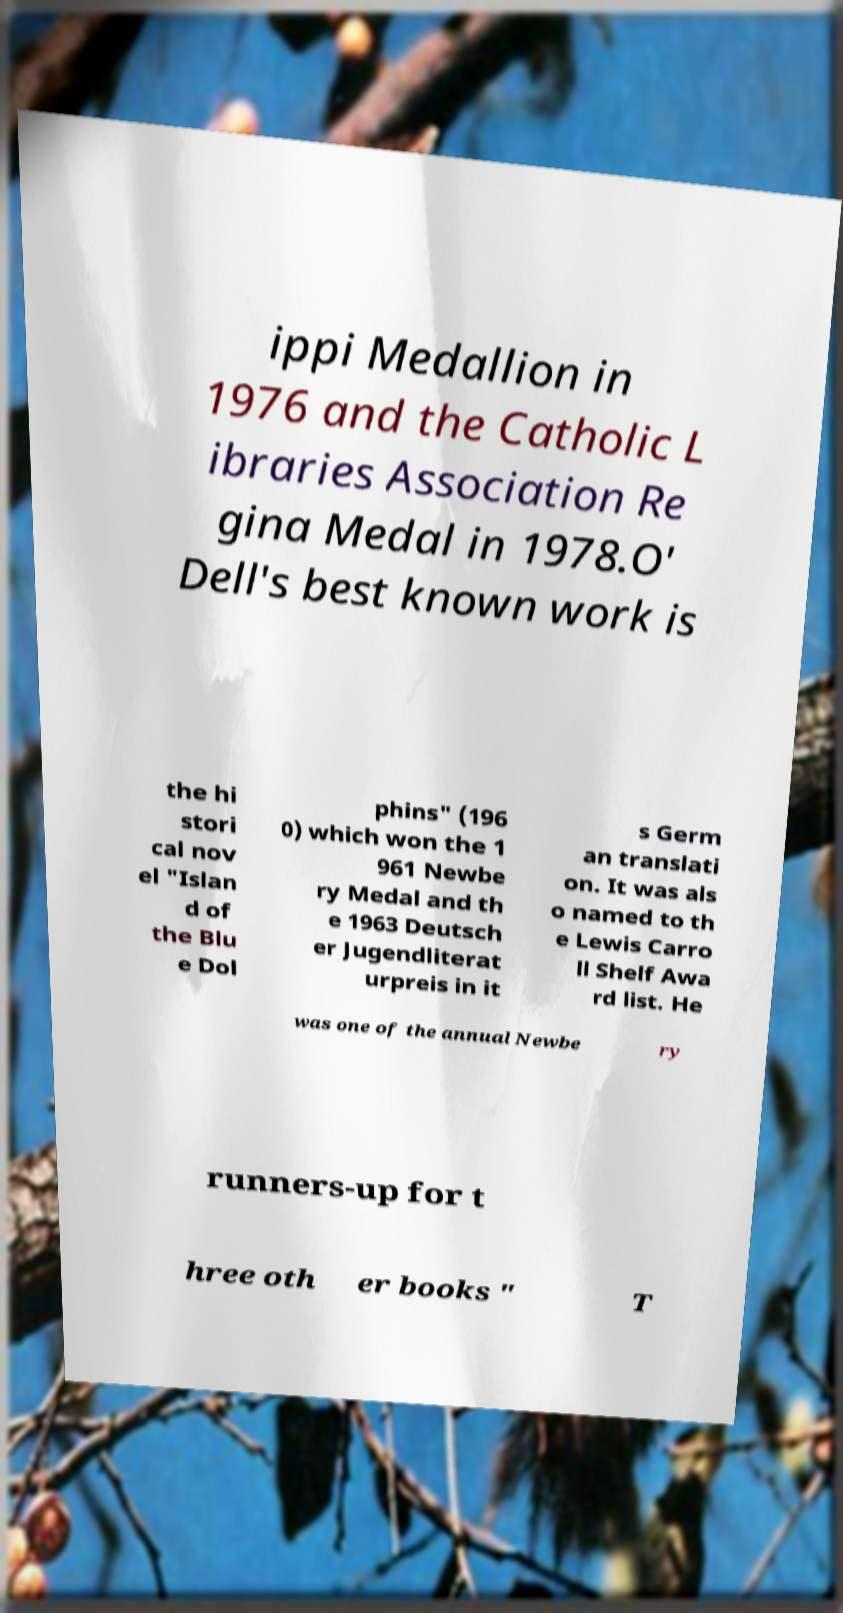I need the written content from this picture converted into text. Can you do that? ippi Medallion in 1976 and the Catholic L ibraries Association Re gina Medal in 1978.O' Dell's best known work is the hi stori cal nov el "Islan d of the Blu e Dol phins" (196 0) which won the 1 961 Newbe ry Medal and th e 1963 Deutsch er Jugendliterat urpreis in it s Germ an translati on. It was als o named to th e Lewis Carro ll Shelf Awa rd list. He was one of the annual Newbe ry runners-up for t hree oth er books " T 